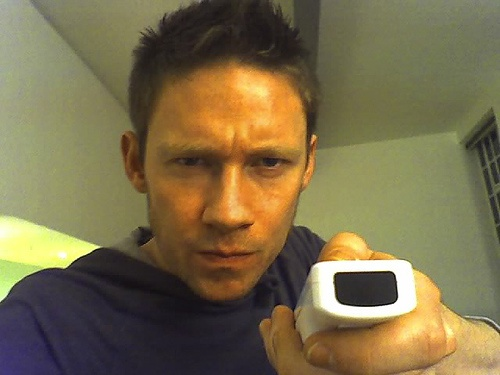Describe the objects in this image and their specific colors. I can see people in darkgray, black, olive, and maroon tones and remote in darkgray, white, black, olive, and gray tones in this image. 